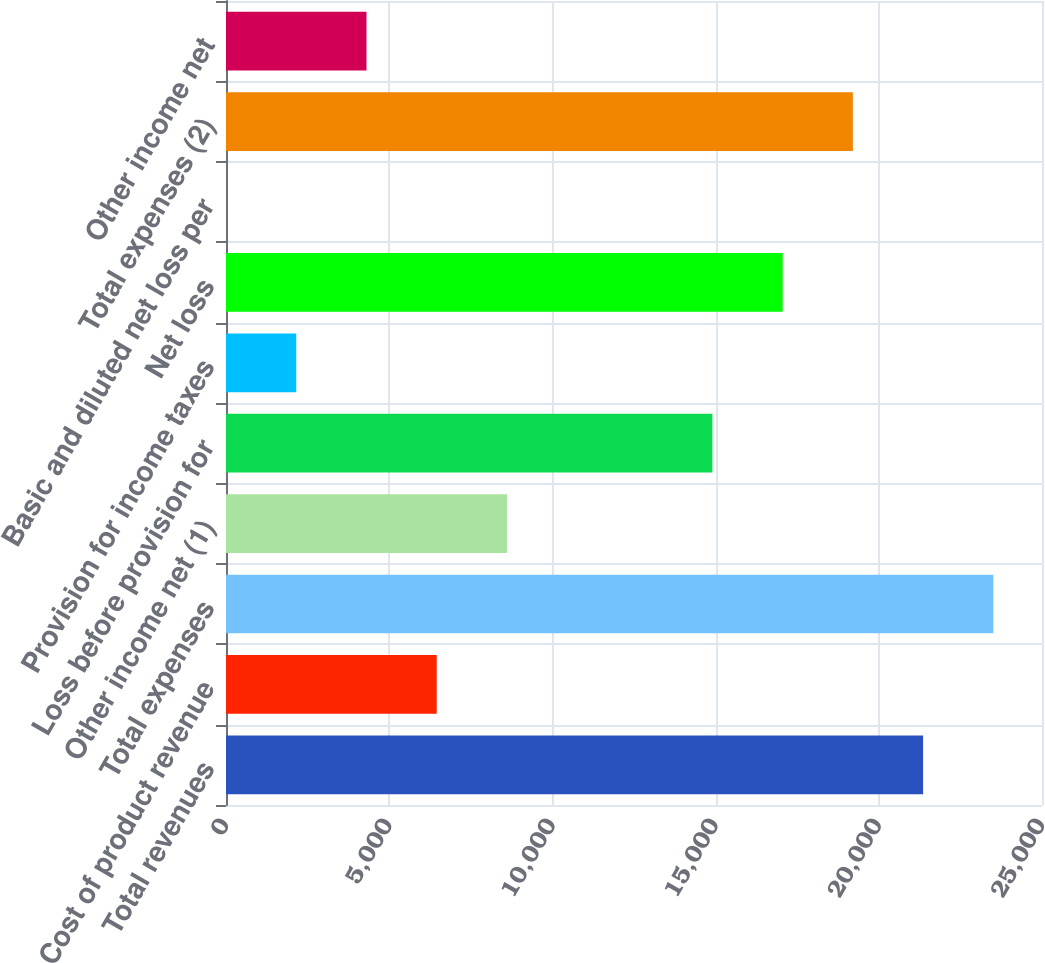<chart> <loc_0><loc_0><loc_500><loc_500><bar_chart><fcel>Total revenues<fcel>Cost of product revenue<fcel>Total expenses<fcel>Other income net (1)<fcel>Loss before provision for<fcel>Provision for income taxes<fcel>Net loss<fcel>Basic and diluted net loss per<fcel>Total expenses (2)<fcel>Other income net<nl><fcel>21357.5<fcel>6456.01<fcel>23509.4<fcel>8607.86<fcel>14902<fcel>2152.31<fcel>17053.8<fcel>0.46<fcel>19205.7<fcel>4304.16<nl></chart> 